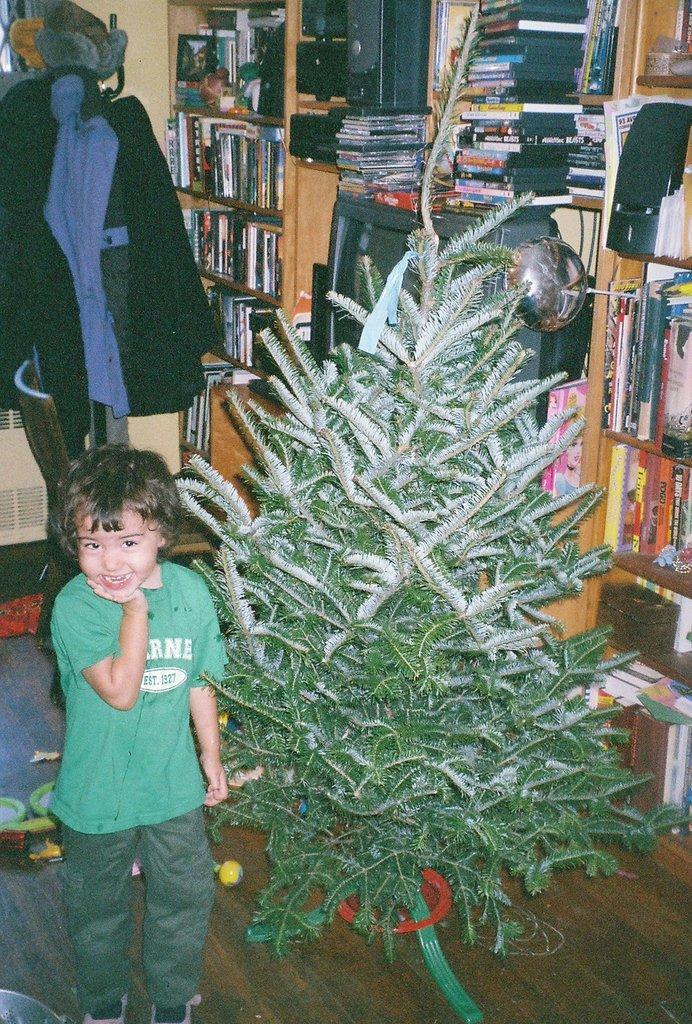Could you give a brief overview of what you see in this image? In this image we can see a child wearing a green T-shirt is smiling and standing on the wooden floor. Here we can see the Christmas tree, books, television and speakers are kept on the shelf. In the background, we can see sweaters hanged on the wall. 